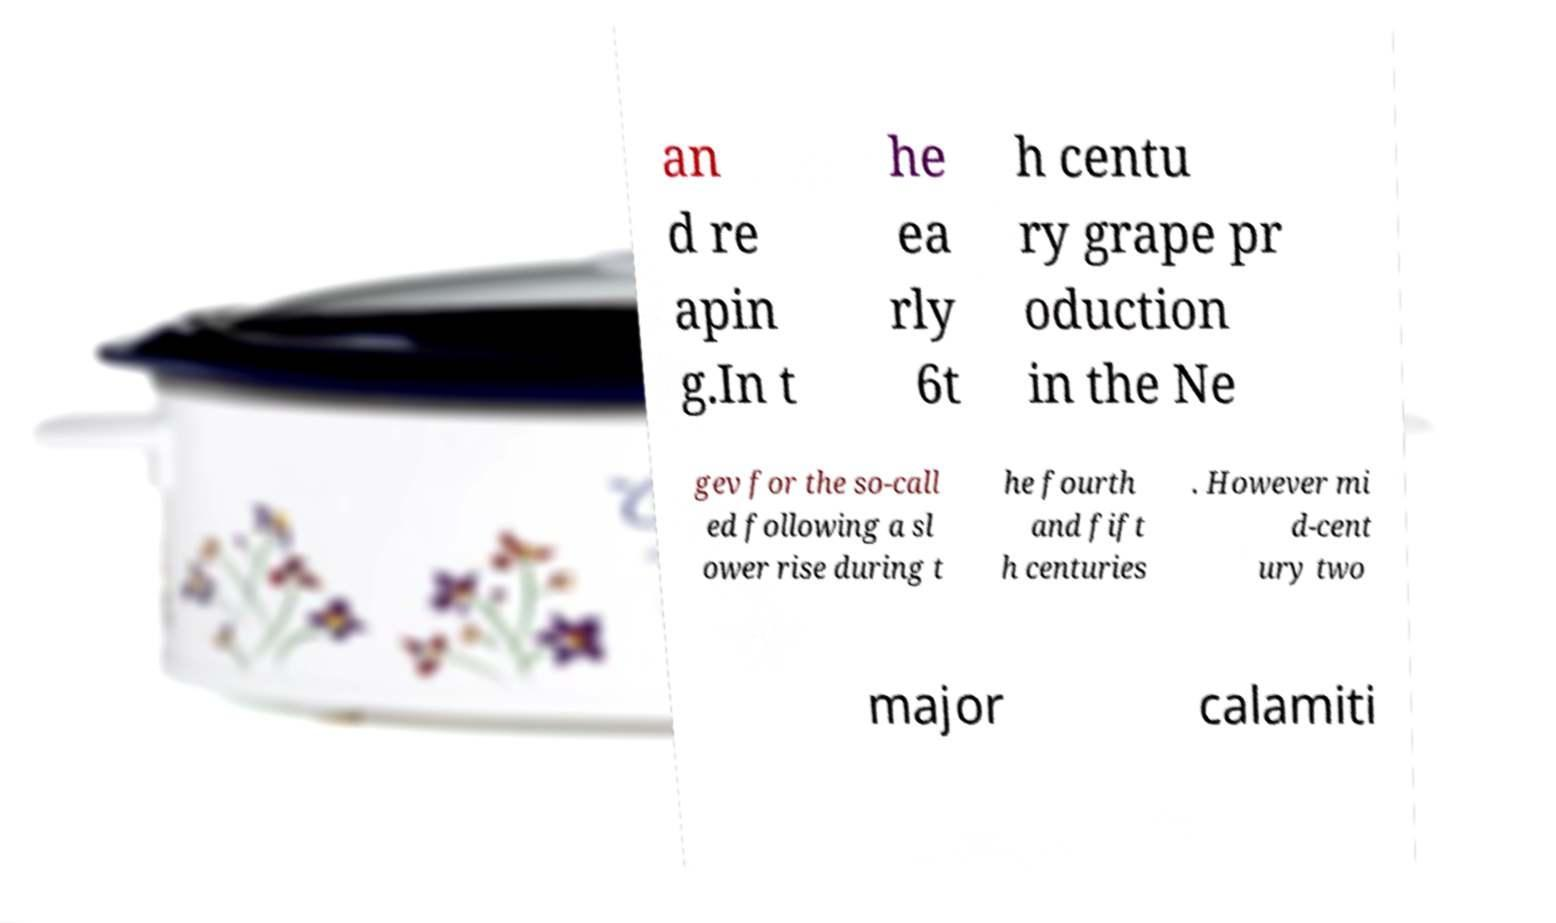For documentation purposes, I need the text within this image transcribed. Could you provide that? an d re apin g.In t he ea rly 6t h centu ry grape pr oduction in the Ne gev for the so-call ed following a sl ower rise during t he fourth and fift h centuries . However mi d-cent ury two major calamiti 